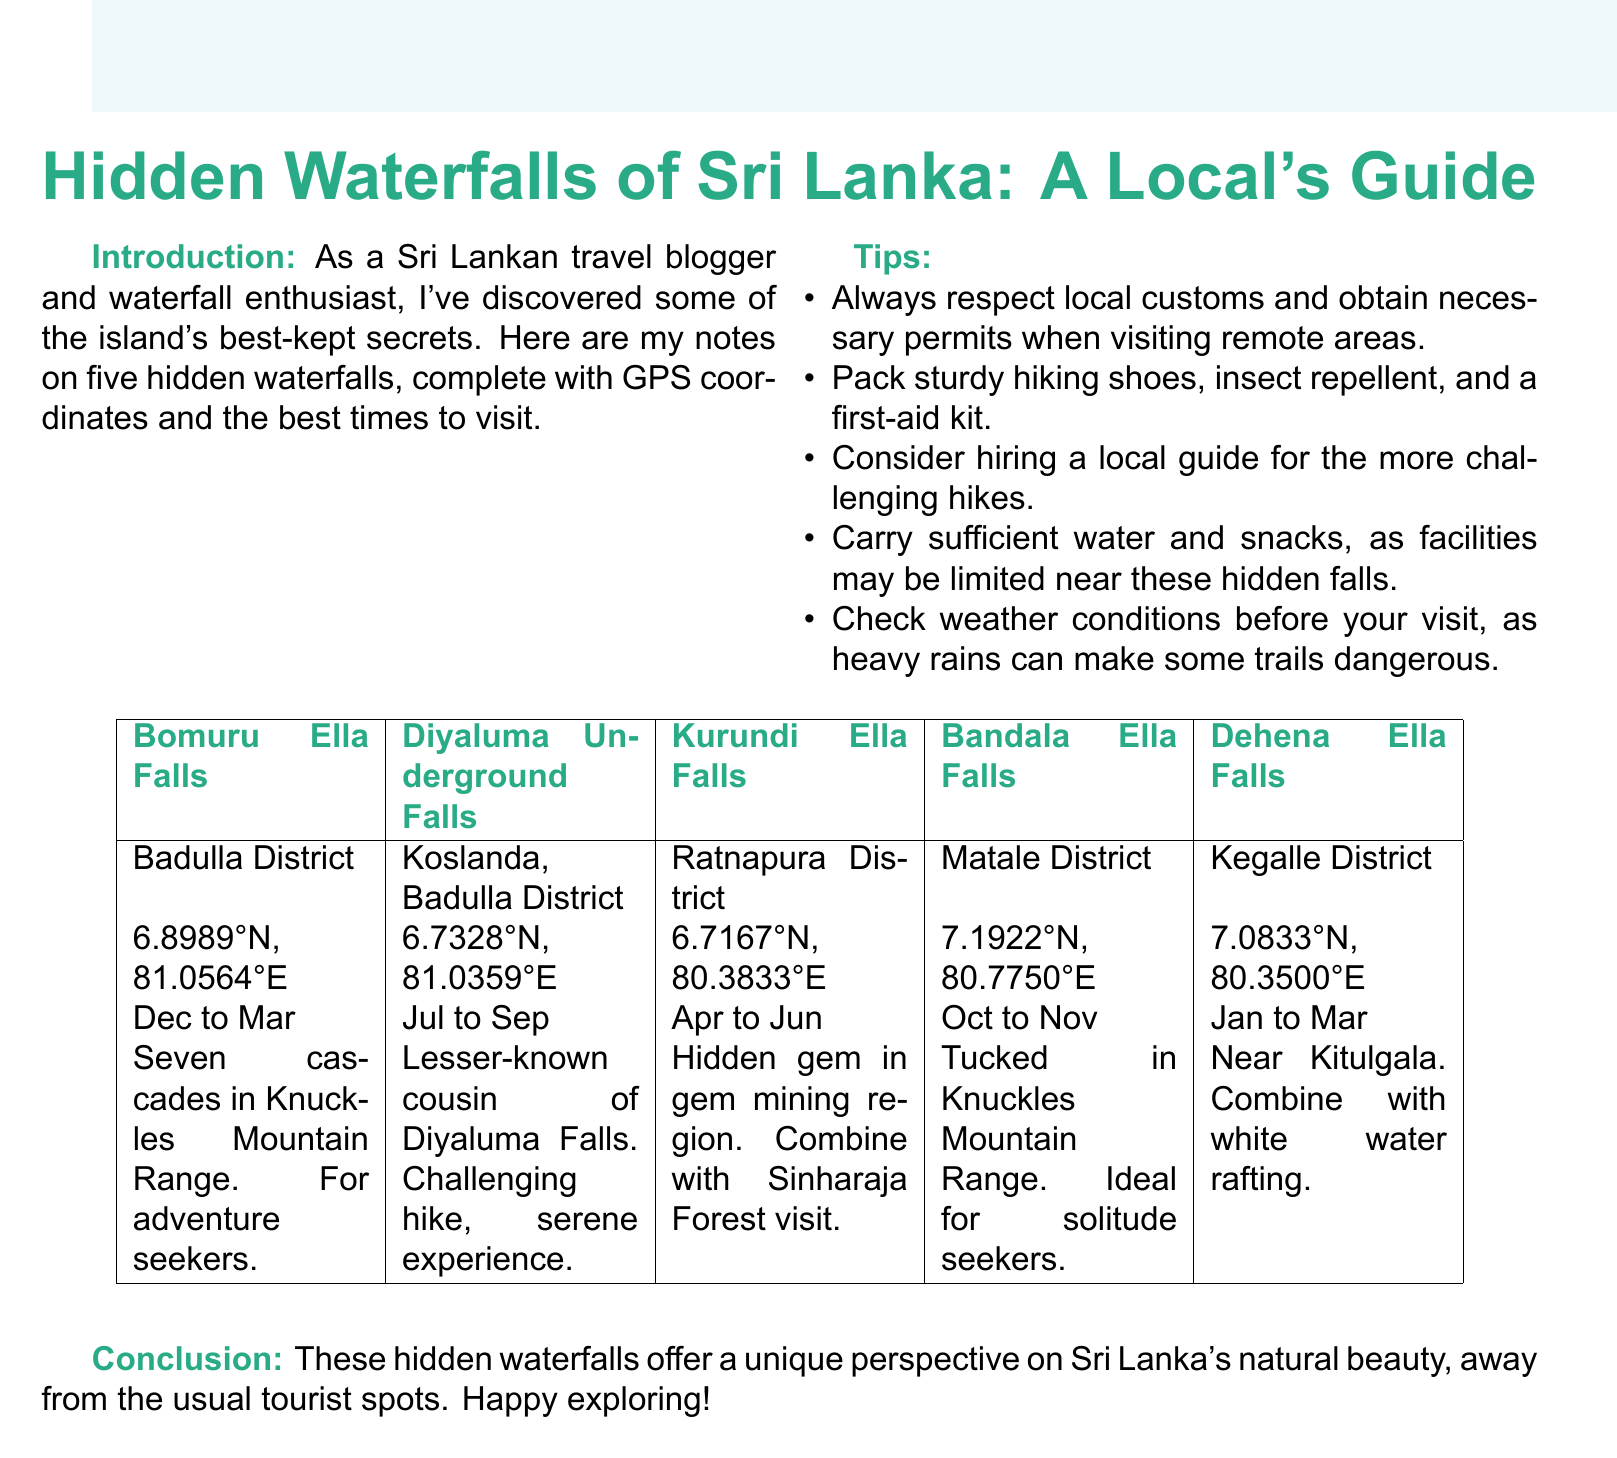What is the name of the waterfall in Badulla District? The document lists Bomuru Ella Falls as the waterfall located in Badulla District.
Answer: Bomuru Ella Falls What are the GPS coordinates of Dehena Ella Falls? The coordinates for Dehena Ella Falls are found in the table provided in the document.
Answer: 7.0833°N, 80.3500°E What is the best time to visit Kurundi Ella Falls? The document states that the optimal visiting period for Kurundi Ella Falls is between April and June.
Answer: April to June Which waterfall is described as ideal for solitude seekers? The document mentions Bandala Ella Falls as being ideal for those seeking solitude and unspoiled nature.
Answer: Bandala Ella Falls What location is associated with Diyaluma Underground Falls? The document specifies that Diyaluma Underground Falls is located in Koslanda, Badulla District.
Answer: Koslanda, Badulla District What advice is given for more challenging hikes? The document suggests considering hiring a local guide for more challenging hikes.
Answer: Hiring a local guide How many cascades are in Bomuru Ella Falls? The notes provide that Bomuru Ella Falls consists of a series of seven cascades.
Answer: Seven cascades What unique experience does Dehena Ella Falls offer? The document indicates that Dehena Ella Falls is perfect for combining with white water rafting adventures.
Answer: White water rafting adventures What is the best time to visit Diyaluma Underground Falls? The document specifies that the best time to visit is from July to September.
Answer: July to September 